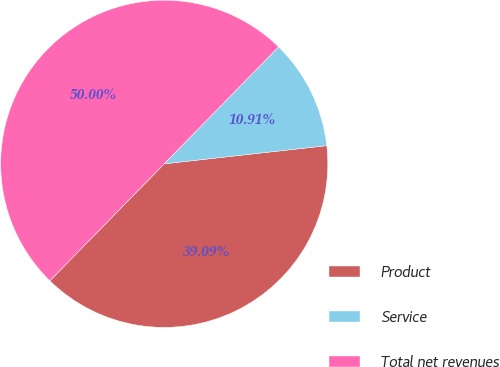<chart> <loc_0><loc_0><loc_500><loc_500><pie_chart><fcel>Product<fcel>Service<fcel>Total net revenues<nl><fcel>39.09%<fcel>10.91%<fcel>50.0%<nl></chart> 